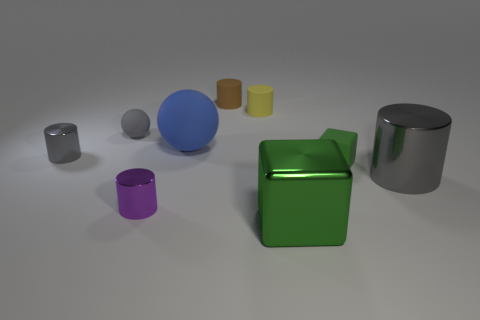There is a small sphere that is the same color as the big cylinder; what is it made of?
Keep it short and to the point. Rubber. What number of yellow things have the same material as the purple thing?
Provide a short and direct response. 0. Are any big gray spheres visible?
Your answer should be compact. No. What size is the shiny cylinder that is right of the green metal block?
Provide a succinct answer. Large. How many other cubes have the same color as the big metal block?
Provide a short and direct response. 1. How many spheres are either small green objects or large things?
Keep it short and to the point. 1. What shape is the gray object that is in front of the tiny rubber ball and behind the big gray shiny object?
Your answer should be very brief. Cylinder. Are there any purple shiny balls of the same size as the purple metal thing?
Ensure brevity in your answer.  No. What number of objects are either objects that are on the right side of the blue sphere or big gray matte cylinders?
Your answer should be compact. 5. Does the small yellow cylinder have the same material as the cylinder on the left side of the small purple metal cylinder?
Your answer should be very brief. No. 